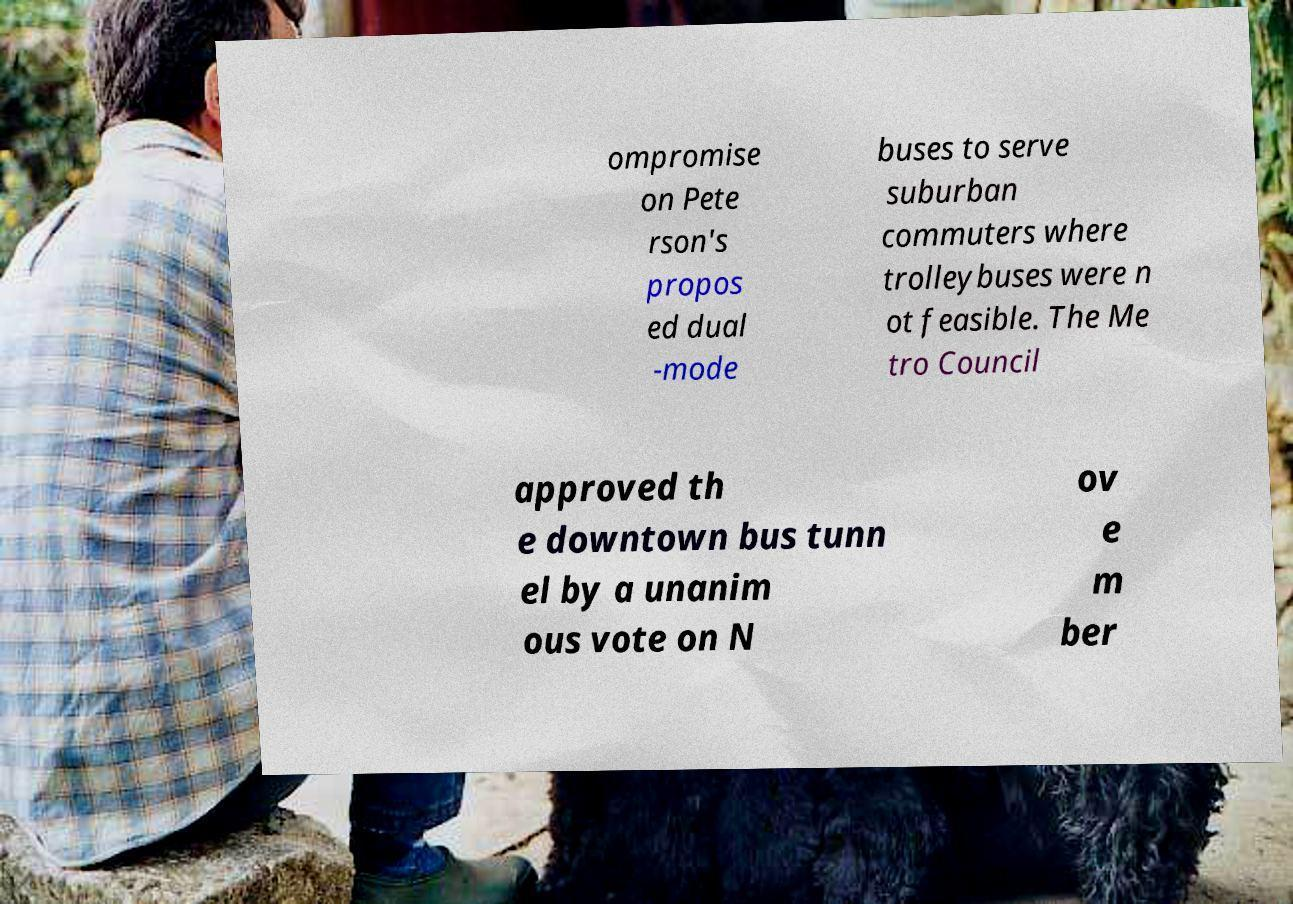What messages or text are displayed in this image? I need them in a readable, typed format. ompromise on Pete rson's propos ed dual -mode buses to serve suburban commuters where trolleybuses were n ot feasible. The Me tro Council approved th e downtown bus tunn el by a unanim ous vote on N ov e m ber 